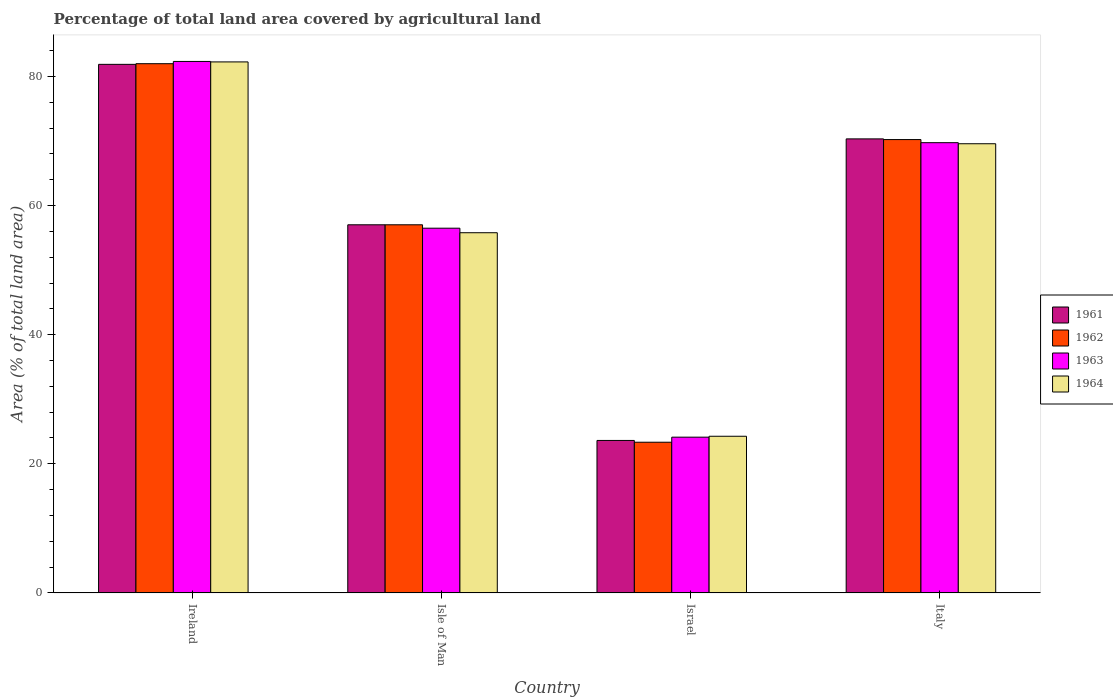How many groups of bars are there?
Provide a succinct answer. 4. Are the number of bars per tick equal to the number of legend labels?
Your answer should be very brief. Yes. How many bars are there on the 4th tick from the left?
Provide a succinct answer. 4. How many bars are there on the 1st tick from the right?
Offer a terse response. 4. What is the label of the 3rd group of bars from the left?
Provide a short and direct response. Israel. What is the percentage of agricultural land in 1961 in Italy?
Offer a terse response. 70.32. Across all countries, what is the maximum percentage of agricultural land in 1964?
Your answer should be compact. 82.25. Across all countries, what is the minimum percentage of agricultural land in 1964?
Ensure brevity in your answer.  24.26. In which country was the percentage of agricultural land in 1964 maximum?
Provide a short and direct response. Ireland. What is the total percentage of agricultural land in 1961 in the graph?
Your response must be concise. 232.82. What is the difference between the percentage of agricultural land in 1961 in Ireland and that in Italy?
Keep it short and to the point. 11.55. What is the difference between the percentage of agricultural land in 1962 in Isle of Man and the percentage of agricultural land in 1961 in Ireland?
Keep it short and to the point. -24.85. What is the average percentage of agricultural land in 1962 per country?
Make the answer very short. 58.14. What is the difference between the percentage of agricultural land of/in 1963 and percentage of agricultural land of/in 1961 in Italy?
Make the answer very short. -0.59. What is the ratio of the percentage of agricultural land in 1964 in Israel to that in Italy?
Provide a succinct answer. 0.35. Is the percentage of agricultural land in 1963 in Israel less than that in Italy?
Offer a very short reply. Yes. What is the difference between the highest and the second highest percentage of agricultural land in 1962?
Give a very brief answer. 11.75. What is the difference between the highest and the lowest percentage of agricultural land in 1962?
Keep it short and to the point. 58.63. In how many countries, is the percentage of agricultural land in 1964 greater than the average percentage of agricultural land in 1964 taken over all countries?
Ensure brevity in your answer.  2. Is it the case that in every country, the sum of the percentage of agricultural land in 1961 and percentage of agricultural land in 1964 is greater than the percentage of agricultural land in 1962?
Make the answer very short. Yes. Are all the bars in the graph horizontal?
Provide a succinct answer. No. What is the difference between two consecutive major ticks on the Y-axis?
Your answer should be very brief. 20. Are the values on the major ticks of Y-axis written in scientific E-notation?
Your answer should be very brief. No. Where does the legend appear in the graph?
Keep it short and to the point. Center right. How many legend labels are there?
Offer a terse response. 4. What is the title of the graph?
Offer a very short reply. Percentage of total land area covered by agricultural land. Does "1998" appear as one of the legend labels in the graph?
Give a very brief answer. No. What is the label or title of the Y-axis?
Give a very brief answer. Area (% of total land area). What is the Area (% of total land area) of 1961 in Ireland?
Your answer should be compact. 81.87. What is the Area (% of total land area) in 1962 in Ireland?
Provide a succinct answer. 81.97. What is the Area (% of total land area) of 1963 in Ireland?
Your answer should be very brief. 82.32. What is the Area (% of total land area) of 1964 in Ireland?
Provide a succinct answer. 82.25. What is the Area (% of total land area) of 1961 in Isle of Man?
Give a very brief answer. 57.02. What is the Area (% of total land area) of 1962 in Isle of Man?
Provide a short and direct response. 57.02. What is the Area (% of total land area) in 1963 in Isle of Man?
Your response must be concise. 56.49. What is the Area (% of total land area) of 1964 in Isle of Man?
Keep it short and to the point. 55.79. What is the Area (% of total land area) in 1961 in Israel?
Ensure brevity in your answer.  23.61. What is the Area (% of total land area) of 1962 in Israel?
Offer a very short reply. 23.34. What is the Area (% of total land area) in 1963 in Israel?
Your answer should be very brief. 24.12. What is the Area (% of total land area) in 1964 in Israel?
Your answer should be compact. 24.26. What is the Area (% of total land area) in 1961 in Italy?
Offer a terse response. 70.32. What is the Area (% of total land area) of 1962 in Italy?
Ensure brevity in your answer.  70.22. What is the Area (% of total land area) in 1963 in Italy?
Your answer should be very brief. 69.74. What is the Area (% of total land area) in 1964 in Italy?
Your answer should be very brief. 69.57. Across all countries, what is the maximum Area (% of total land area) in 1961?
Your response must be concise. 81.87. Across all countries, what is the maximum Area (% of total land area) in 1962?
Your answer should be compact. 81.97. Across all countries, what is the maximum Area (% of total land area) in 1963?
Give a very brief answer. 82.32. Across all countries, what is the maximum Area (% of total land area) in 1964?
Provide a short and direct response. 82.25. Across all countries, what is the minimum Area (% of total land area) of 1961?
Your answer should be very brief. 23.61. Across all countries, what is the minimum Area (% of total land area) in 1962?
Your answer should be compact. 23.34. Across all countries, what is the minimum Area (% of total land area) of 1963?
Ensure brevity in your answer.  24.12. Across all countries, what is the minimum Area (% of total land area) in 1964?
Give a very brief answer. 24.26. What is the total Area (% of total land area) of 1961 in the graph?
Keep it short and to the point. 232.82. What is the total Area (% of total land area) of 1962 in the graph?
Provide a short and direct response. 232.54. What is the total Area (% of total land area) of 1963 in the graph?
Give a very brief answer. 232.67. What is the total Area (% of total land area) in 1964 in the graph?
Provide a succinct answer. 231.87. What is the difference between the Area (% of total land area) of 1961 in Ireland and that in Isle of Man?
Give a very brief answer. 24.85. What is the difference between the Area (% of total land area) in 1962 in Ireland and that in Isle of Man?
Offer a terse response. 24.95. What is the difference between the Area (% of total land area) in 1963 in Ireland and that in Isle of Man?
Your answer should be very brief. 25.83. What is the difference between the Area (% of total land area) in 1964 in Ireland and that in Isle of Man?
Keep it short and to the point. 26.46. What is the difference between the Area (% of total land area) of 1961 in Ireland and that in Israel?
Your response must be concise. 58.26. What is the difference between the Area (% of total land area) of 1962 in Ireland and that in Israel?
Give a very brief answer. 58.63. What is the difference between the Area (% of total land area) of 1963 in Ireland and that in Israel?
Provide a short and direct response. 58.2. What is the difference between the Area (% of total land area) in 1964 in Ireland and that in Israel?
Offer a terse response. 57.99. What is the difference between the Area (% of total land area) of 1961 in Ireland and that in Italy?
Make the answer very short. 11.55. What is the difference between the Area (% of total land area) in 1962 in Ireland and that in Italy?
Provide a succinct answer. 11.75. What is the difference between the Area (% of total land area) in 1963 in Ireland and that in Italy?
Make the answer very short. 12.58. What is the difference between the Area (% of total land area) of 1964 in Ireland and that in Italy?
Keep it short and to the point. 12.67. What is the difference between the Area (% of total land area) in 1961 in Isle of Man and that in Israel?
Your answer should be compact. 33.4. What is the difference between the Area (% of total land area) of 1962 in Isle of Man and that in Israel?
Make the answer very short. 33.68. What is the difference between the Area (% of total land area) of 1963 in Isle of Man and that in Israel?
Your answer should be very brief. 32.37. What is the difference between the Area (% of total land area) in 1964 in Isle of Man and that in Israel?
Your answer should be very brief. 31.53. What is the difference between the Area (% of total land area) in 1961 in Isle of Man and that in Italy?
Provide a short and direct response. -13.31. What is the difference between the Area (% of total land area) in 1962 in Isle of Man and that in Italy?
Provide a short and direct response. -13.2. What is the difference between the Area (% of total land area) in 1963 in Isle of Man and that in Italy?
Make the answer very short. -13.24. What is the difference between the Area (% of total land area) of 1964 in Isle of Man and that in Italy?
Keep it short and to the point. -13.78. What is the difference between the Area (% of total land area) of 1961 in Israel and that in Italy?
Make the answer very short. -46.71. What is the difference between the Area (% of total land area) of 1962 in Israel and that in Italy?
Your answer should be compact. -46.88. What is the difference between the Area (% of total land area) of 1963 in Israel and that in Italy?
Keep it short and to the point. -45.61. What is the difference between the Area (% of total land area) in 1964 in Israel and that in Italy?
Your response must be concise. -45.31. What is the difference between the Area (% of total land area) in 1961 in Ireland and the Area (% of total land area) in 1962 in Isle of Man?
Your response must be concise. 24.85. What is the difference between the Area (% of total land area) in 1961 in Ireland and the Area (% of total land area) in 1963 in Isle of Man?
Give a very brief answer. 25.38. What is the difference between the Area (% of total land area) of 1961 in Ireland and the Area (% of total land area) of 1964 in Isle of Man?
Offer a terse response. 26.08. What is the difference between the Area (% of total land area) in 1962 in Ireland and the Area (% of total land area) in 1963 in Isle of Man?
Provide a succinct answer. 25.48. What is the difference between the Area (% of total land area) of 1962 in Ireland and the Area (% of total land area) of 1964 in Isle of Man?
Provide a succinct answer. 26.18. What is the difference between the Area (% of total land area) in 1963 in Ireland and the Area (% of total land area) in 1964 in Isle of Man?
Your answer should be very brief. 26.53. What is the difference between the Area (% of total land area) of 1961 in Ireland and the Area (% of total land area) of 1962 in Israel?
Your response must be concise. 58.53. What is the difference between the Area (% of total land area) of 1961 in Ireland and the Area (% of total land area) of 1963 in Israel?
Your response must be concise. 57.75. What is the difference between the Area (% of total land area) in 1961 in Ireland and the Area (% of total land area) in 1964 in Israel?
Offer a very short reply. 57.61. What is the difference between the Area (% of total land area) in 1962 in Ireland and the Area (% of total land area) in 1963 in Israel?
Keep it short and to the point. 57.85. What is the difference between the Area (% of total land area) in 1962 in Ireland and the Area (% of total land area) in 1964 in Israel?
Your response must be concise. 57.71. What is the difference between the Area (% of total land area) of 1963 in Ireland and the Area (% of total land area) of 1964 in Israel?
Provide a succinct answer. 58.06. What is the difference between the Area (% of total land area) of 1961 in Ireland and the Area (% of total land area) of 1962 in Italy?
Ensure brevity in your answer.  11.65. What is the difference between the Area (% of total land area) of 1961 in Ireland and the Area (% of total land area) of 1963 in Italy?
Offer a very short reply. 12.13. What is the difference between the Area (% of total land area) of 1961 in Ireland and the Area (% of total land area) of 1964 in Italy?
Ensure brevity in your answer.  12.3. What is the difference between the Area (% of total land area) of 1962 in Ireland and the Area (% of total land area) of 1963 in Italy?
Your response must be concise. 12.24. What is the difference between the Area (% of total land area) in 1962 in Ireland and the Area (% of total land area) in 1964 in Italy?
Ensure brevity in your answer.  12.4. What is the difference between the Area (% of total land area) in 1963 in Ireland and the Area (% of total land area) in 1964 in Italy?
Make the answer very short. 12.75. What is the difference between the Area (% of total land area) of 1961 in Isle of Man and the Area (% of total land area) of 1962 in Israel?
Provide a short and direct response. 33.68. What is the difference between the Area (% of total land area) of 1961 in Isle of Man and the Area (% of total land area) of 1963 in Israel?
Keep it short and to the point. 32.9. What is the difference between the Area (% of total land area) of 1961 in Isle of Man and the Area (% of total land area) of 1964 in Israel?
Keep it short and to the point. 32.76. What is the difference between the Area (% of total land area) in 1962 in Isle of Man and the Area (% of total land area) in 1963 in Israel?
Your answer should be compact. 32.9. What is the difference between the Area (% of total land area) in 1962 in Isle of Man and the Area (% of total land area) in 1964 in Israel?
Your answer should be compact. 32.76. What is the difference between the Area (% of total land area) of 1963 in Isle of Man and the Area (% of total land area) of 1964 in Israel?
Offer a terse response. 32.23. What is the difference between the Area (% of total land area) in 1961 in Isle of Man and the Area (% of total land area) in 1962 in Italy?
Keep it short and to the point. -13.2. What is the difference between the Area (% of total land area) of 1961 in Isle of Man and the Area (% of total land area) of 1963 in Italy?
Give a very brief answer. -12.72. What is the difference between the Area (% of total land area) in 1961 in Isle of Man and the Area (% of total land area) in 1964 in Italy?
Your answer should be very brief. -12.56. What is the difference between the Area (% of total land area) of 1962 in Isle of Man and the Area (% of total land area) of 1963 in Italy?
Offer a terse response. -12.72. What is the difference between the Area (% of total land area) in 1962 in Isle of Man and the Area (% of total land area) in 1964 in Italy?
Provide a short and direct response. -12.56. What is the difference between the Area (% of total land area) of 1963 in Isle of Man and the Area (% of total land area) of 1964 in Italy?
Offer a very short reply. -13.08. What is the difference between the Area (% of total land area) of 1961 in Israel and the Area (% of total land area) of 1962 in Italy?
Provide a succinct answer. -46.6. What is the difference between the Area (% of total land area) of 1961 in Israel and the Area (% of total land area) of 1963 in Italy?
Ensure brevity in your answer.  -46.12. What is the difference between the Area (% of total land area) of 1961 in Israel and the Area (% of total land area) of 1964 in Italy?
Your answer should be compact. -45.96. What is the difference between the Area (% of total land area) in 1962 in Israel and the Area (% of total land area) in 1963 in Italy?
Ensure brevity in your answer.  -46.4. What is the difference between the Area (% of total land area) of 1962 in Israel and the Area (% of total land area) of 1964 in Italy?
Your answer should be very brief. -46.24. What is the difference between the Area (% of total land area) of 1963 in Israel and the Area (% of total land area) of 1964 in Italy?
Provide a short and direct response. -45.45. What is the average Area (% of total land area) in 1961 per country?
Keep it short and to the point. 58.21. What is the average Area (% of total land area) of 1962 per country?
Offer a terse response. 58.14. What is the average Area (% of total land area) of 1963 per country?
Keep it short and to the point. 58.17. What is the average Area (% of total land area) in 1964 per country?
Make the answer very short. 57.97. What is the difference between the Area (% of total land area) in 1961 and Area (% of total land area) in 1962 in Ireland?
Offer a very short reply. -0.1. What is the difference between the Area (% of total land area) of 1961 and Area (% of total land area) of 1963 in Ireland?
Your response must be concise. -0.45. What is the difference between the Area (% of total land area) in 1961 and Area (% of total land area) in 1964 in Ireland?
Offer a terse response. -0.38. What is the difference between the Area (% of total land area) in 1962 and Area (% of total land area) in 1963 in Ireland?
Keep it short and to the point. -0.35. What is the difference between the Area (% of total land area) in 1962 and Area (% of total land area) in 1964 in Ireland?
Offer a terse response. -0.28. What is the difference between the Area (% of total land area) in 1963 and Area (% of total land area) in 1964 in Ireland?
Give a very brief answer. 0.07. What is the difference between the Area (% of total land area) of 1961 and Area (% of total land area) of 1963 in Isle of Man?
Offer a very short reply. 0.53. What is the difference between the Area (% of total land area) in 1961 and Area (% of total land area) in 1964 in Isle of Man?
Your response must be concise. 1.23. What is the difference between the Area (% of total land area) in 1962 and Area (% of total land area) in 1963 in Isle of Man?
Offer a terse response. 0.53. What is the difference between the Area (% of total land area) of 1962 and Area (% of total land area) of 1964 in Isle of Man?
Make the answer very short. 1.23. What is the difference between the Area (% of total land area) in 1963 and Area (% of total land area) in 1964 in Isle of Man?
Offer a very short reply. 0.7. What is the difference between the Area (% of total land area) of 1961 and Area (% of total land area) of 1962 in Israel?
Offer a very short reply. 0.28. What is the difference between the Area (% of total land area) of 1961 and Area (% of total land area) of 1963 in Israel?
Your response must be concise. -0.51. What is the difference between the Area (% of total land area) of 1961 and Area (% of total land area) of 1964 in Israel?
Your answer should be compact. -0.65. What is the difference between the Area (% of total land area) of 1962 and Area (% of total land area) of 1963 in Israel?
Your answer should be very brief. -0.79. What is the difference between the Area (% of total land area) in 1962 and Area (% of total land area) in 1964 in Israel?
Your response must be concise. -0.92. What is the difference between the Area (% of total land area) in 1963 and Area (% of total land area) in 1964 in Israel?
Your answer should be very brief. -0.14. What is the difference between the Area (% of total land area) of 1961 and Area (% of total land area) of 1962 in Italy?
Offer a terse response. 0.11. What is the difference between the Area (% of total land area) of 1961 and Area (% of total land area) of 1963 in Italy?
Offer a terse response. 0.59. What is the difference between the Area (% of total land area) in 1961 and Area (% of total land area) in 1964 in Italy?
Make the answer very short. 0.75. What is the difference between the Area (% of total land area) of 1962 and Area (% of total land area) of 1963 in Italy?
Make the answer very short. 0.48. What is the difference between the Area (% of total land area) of 1962 and Area (% of total land area) of 1964 in Italy?
Provide a succinct answer. 0.65. What is the difference between the Area (% of total land area) of 1963 and Area (% of total land area) of 1964 in Italy?
Offer a terse response. 0.16. What is the ratio of the Area (% of total land area) of 1961 in Ireland to that in Isle of Man?
Give a very brief answer. 1.44. What is the ratio of the Area (% of total land area) of 1962 in Ireland to that in Isle of Man?
Keep it short and to the point. 1.44. What is the ratio of the Area (% of total land area) in 1963 in Ireland to that in Isle of Man?
Offer a terse response. 1.46. What is the ratio of the Area (% of total land area) of 1964 in Ireland to that in Isle of Man?
Keep it short and to the point. 1.47. What is the ratio of the Area (% of total land area) of 1961 in Ireland to that in Israel?
Your answer should be very brief. 3.47. What is the ratio of the Area (% of total land area) of 1962 in Ireland to that in Israel?
Offer a terse response. 3.51. What is the ratio of the Area (% of total land area) in 1963 in Ireland to that in Israel?
Provide a short and direct response. 3.41. What is the ratio of the Area (% of total land area) in 1964 in Ireland to that in Israel?
Make the answer very short. 3.39. What is the ratio of the Area (% of total land area) of 1961 in Ireland to that in Italy?
Provide a succinct answer. 1.16. What is the ratio of the Area (% of total land area) of 1962 in Ireland to that in Italy?
Your response must be concise. 1.17. What is the ratio of the Area (% of total land area) of 1963 in Ireland to that in Italy?
Provide a succinct answer. 1.18. What is the ratio of the Area (% of total land area) in 1964 in Ireland to that in Italy?
Make the answer very short. 1.18. What is the ratio of the Area (% of total land area) of 1961 in Isle of Man to that in Israel?
Offer a very short reply. 2.41. What is the ratio of the Area (% of total land area) of 1962 in Isle of Man to that in Israel?
Ensure brevity in your answer.  2.44. What is the ratio of the Area (% of total land area) in 1963 in Isle of Man to that in Israel?
Provide a short and direct response. 2.34. What is the ratio of the Area (% of total land area) of 1964 in Isle of Man to that in Israel?
Provide a short and direct response. 2.3. What is the ratio of the Area (% of total land area) in 1961 in Isle of Man to that in Italy?
Make the answer very short. 0.81. What is the ratio of the Area (% of total land area) in 1962 in Isle of Man to that in Italy?
Offer a very short reply. 0.81. What is the ratio of the Area (% of total land area) in 1963 in Isle of Man to that in Italy?
Ensure brevity in your answer.  0.81. What is the ratio of the Area (% of total land area) of 1964 in Isle of Man to that in Italy?
Make the answer very short. 0.8. What is the ratio of the Area (% of total land area) in 1961 in Israel to that in Italy?
Ensure brevity in your answer.  0.34. What is the ratio of the Area (% of total land area) of 1962 in Israel to that in Italy?
Offer a very short reply. 0.33. What is the ratio of the Area (% of total land area) in 1963 in Israel to that in Italy?
Your answer should be compact. 0.35. What is the ratio of the Area (% of total land area) of 1964 in Israel to that in Italy?
Ensure brevity in your answer.  0.35. What is the difference between the highest and the second highest Area (% of total land area) in 1961?
Offer a terse response. 11.55. What is the difference between the highest and the second highest Area (% of total land area) of 1962?
Your answer should be compact. 11.75. What is the difference between the highest and the second highest Area (% of total land area) of 1963?
Offer a terse response. 12.58. What is the difference between the highest and the second highest Area (% of total land area) in 1964?
Offer a terse response. 12.67. What is the difference between the highest and the lowest Area (% of total land area) in 1961?
Make the answer very short. 58.26. What is the difference between the highest and the lowest Area (% of total land area) in 1962?
Offer a very short reply. 58.63. What is the difference between the highest and the lowest Area (% of total land area) of 1963?
Offer a terse response. 58.2. What is the difference between the highest and the lowest Area (% of total land area) in 1964?
Provide a short and direct response. 57.99. 